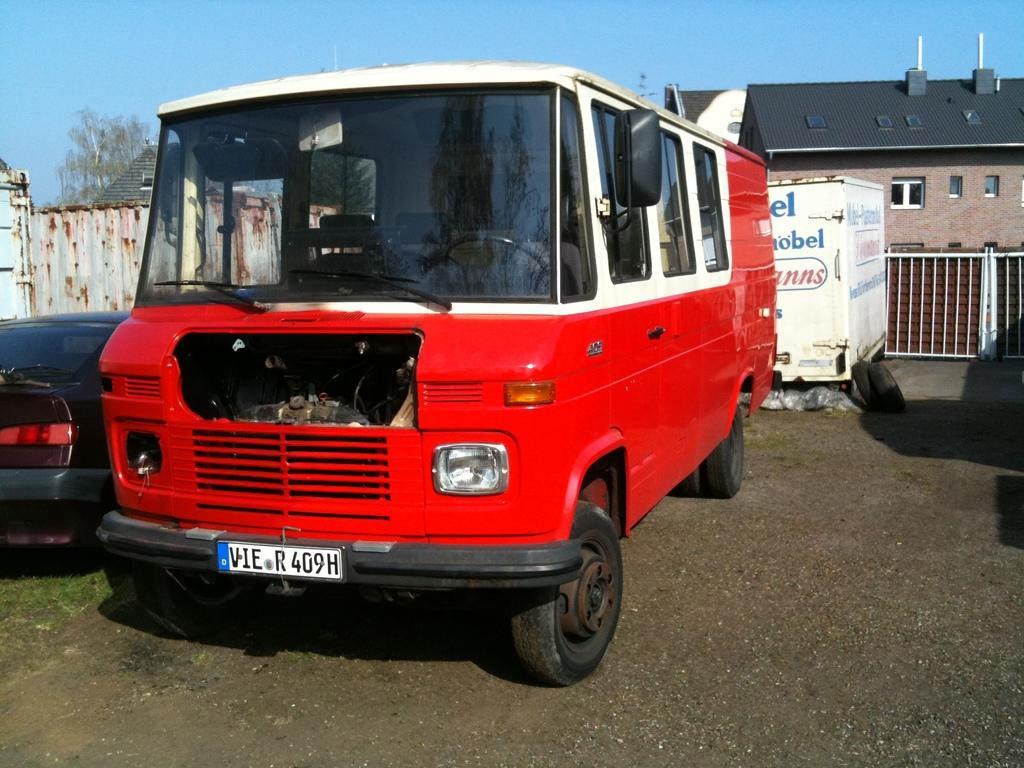What type of vehicle can be seen in the image? There is a bus and a car in the image. What type of terrain is visible in the image? There is grass in the image. What type of structure can be seen in the image? There is a wall, houses, and a gate in the image. What type of openings can be seen in the structures? There are windows in the image. What type of vegetation is visible in the image? There are trees in the image. What can be seen in the background of the image? The sky is visible in the background of the image. What type of egg is being used as a doorstop in the image? There is no egg present in the image, let alone one being used as a doorstop. 